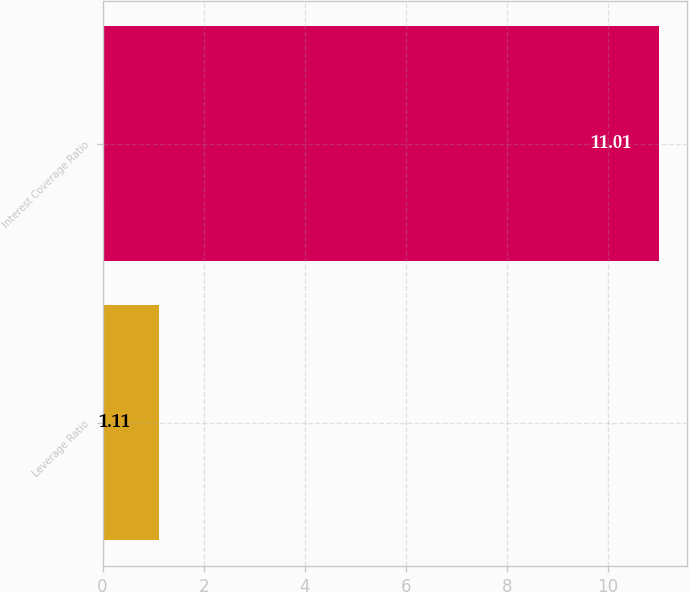<chart> <loc_0><loc_0><loc_500><loc_500><bar_chart><fcel>Leverage Ratio<fcel>Interest Coverage Ratio<nl><fcel>1.11<fcel>11.01<nl></chart> 